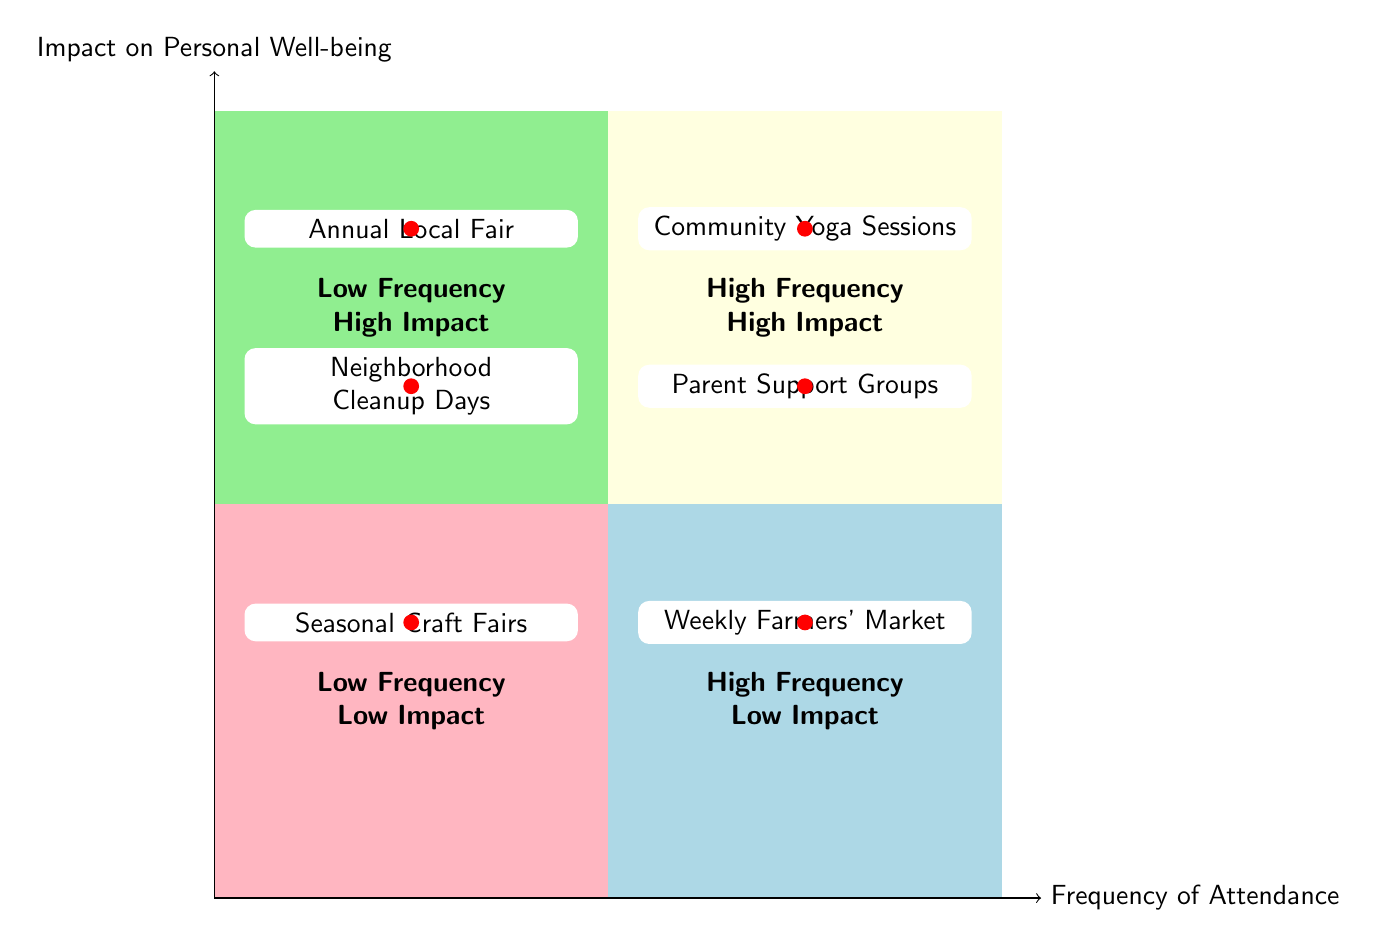What events are in the high frequency, high impact quadrant? The high frequency, high impact quadrant includes Community Yoga Sessions and Parent Support Groups. These events are both attended regularly and have a significant positive effect on personal well-being.
Answer: Community Yoga Sessions, Parent Support Groups How many events are in the low frequency, low impact quadrant? There is only one event listed in the low frequency, low impact quadrant, which is Seasonal Craft Fairs. This indicates that it occurs infrequently and has a limited impact on well-being.
Answer: 1 Which event occurs annually but has a high impact on well-being? The Annual Local Fair occurs once a year but is considered to have a high impact on personal well-being due to its social and relaxing nature.
Answer: Annual Local Fair What type of events are held weekly and have low impact? The Weekly Farmers' Market is held weekly but is classified as having low impact on personal well-being, suggesting it serves more for routine shopping and socializing rather than enhancing mental health.
Answer: Weekly Farmers' Market Are there any community events that are both high frequency and low impact? Yes, the Weekly Farmers' Market is the only event that is attended frequently but is considered to have low impact on personal well-being.
Answer: Yes List two events that have a high impact but low frequency. The two events that have a high impact but low frequency are the Annual Local Fair and Neighborhood Cleanup Days. Both of these provide significant benefits to personal well-being even though they are not attended regularly.
Answer: Annual Local Fair, Neighborhood Cleanup Days What is the primary purpose behind Neighborhood Cleanup Days according to the chart? According to the chart, the primary purpose of Neighborhood Cleanup Days is to provide a sense of accomplishment and community contribution. This highlights its importance in enhancing individual well-being even though it occurs only semi-annually.
Answer: Sense of accomplishment and community contribution Which quadrant contains the Community Yoga Sessions? The Community Yoga Sessions are located in the high frequency, high impact quadrant, indicating that attending these sessions frequently leads to a considerable positive effect on personal well-being.
Answer: High Frequency High Impact What characterizes the events in the low frequency, high impact quadrant? Events in the low frequency, high impact quadrant are characterized by their infrequent occurrence but strong positive benefits on personal well-being, providing meaningful experiences that support mental health despite being held less often.
Answer: Infrequent occurrence, strong positive benefits 